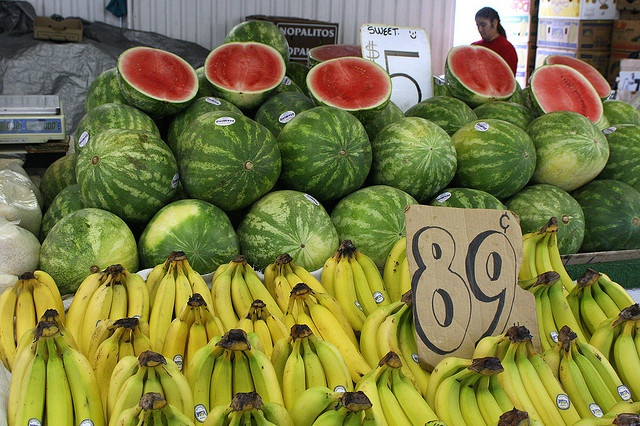Describe the objects in this image and their specific colors. I can see banana in black, olive, and khaki tones, banana in black, olive, and khaki tones, banana in black, olive, and khaki tones, banana in black, olive, khaki, and gold tones, and banana in black, gold, olive, and khaki tones in this image. 